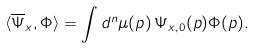<formula> <loc_0><loc_0><loc_500><loc_500>\langle \overline { \Psi } _ { x } , \Phi \rangle = \int d ^ { n } \mu ( p ) \, \Psi _ { x , 0 } ( p ) \Phi ( p ) .</formula> 